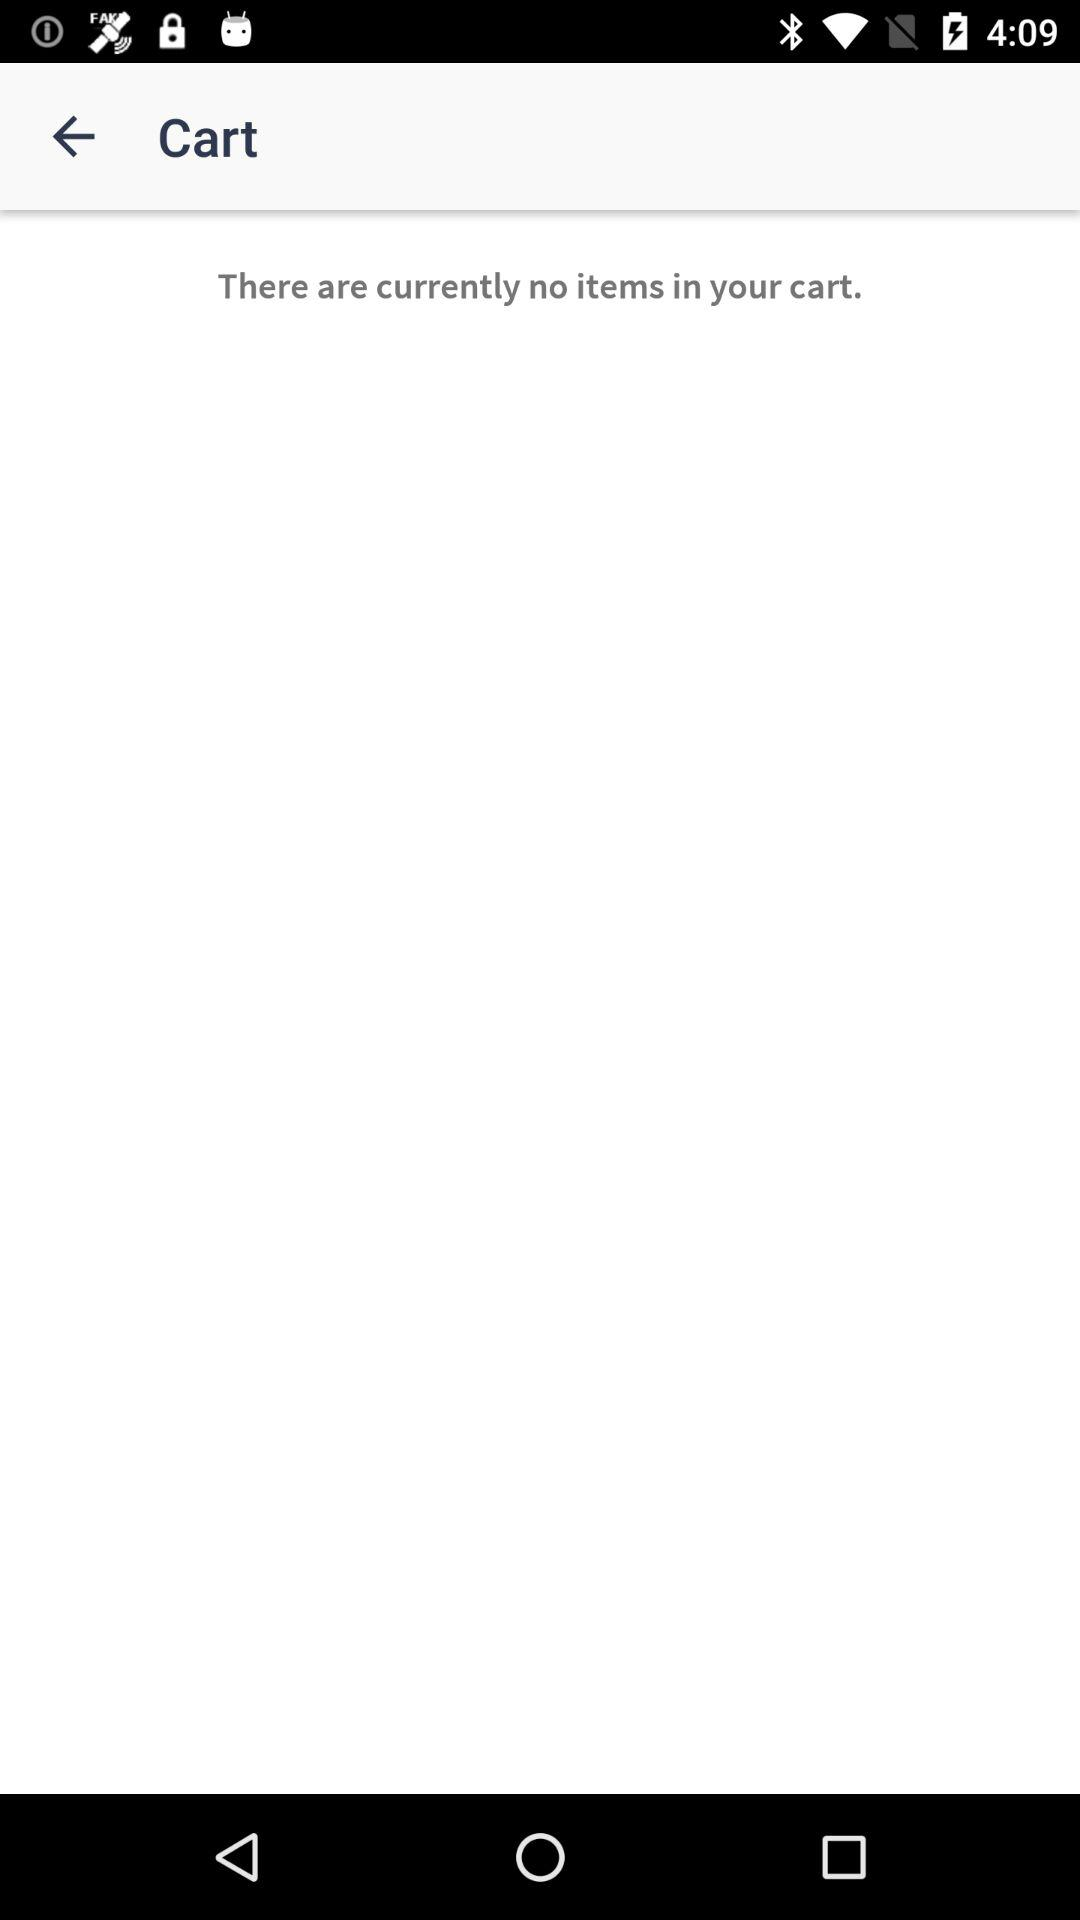How many items are in the cart?
Answer the question using a single word or phrase. 0 